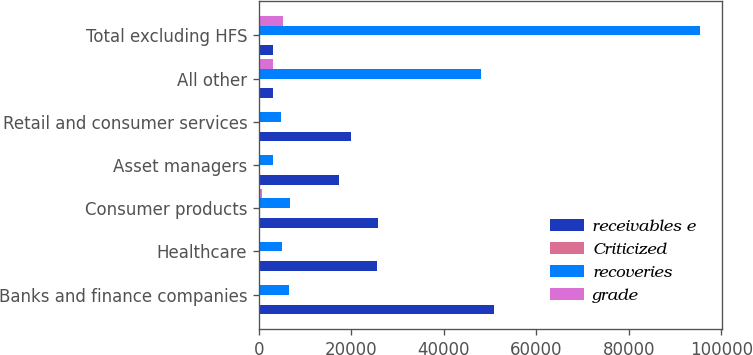Convert chart. <chart><loc_0><loc_0><loc_500><loc_500><stacked_bar_chart><ecel><fcel>Banks and finance companies<fcel>Healthcare<fcel>Consumer products<fcel>Asset managers<fcel>Retail and consumer services<fcel>All other<fcel>Total excluding HFS<nl><fcel>receivables e<fcel>50924<fcel>25435<fcel>25678<fcel>17358<fcel>19920<fcel>3015<fcel>3015<nl><fcel>Criticized<fcel>87<fcel>79<fcel>71<fcel>82<fcel>75<fcel>82<fcel>81<nl><fcel>recoveries<fcel>6462<fcel>4977<fcel>6791<fcel>2949<fcel>4654<fcel>47966<fcel>95375<nl><fcel>grade<fcel>232<fcel>243<fcel>590<fcel>103<fcel>288<fcel>3081<fcel>5172<nl></chart> 